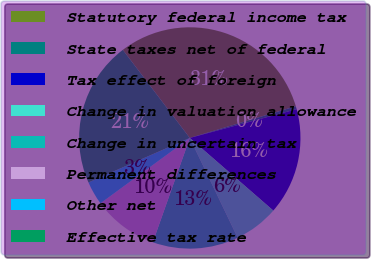Convert chart to OTSL. <chart><loc_0><loc_0><loc_500><loc_500><pie_chart><fcel>Statutory federal income tax<fcel>State taxes net of federal<fcel>Tax effect of foreign<fcel>Change in valuation allowance<fcel>Change in uncertain tax<fcel>Permanent differences<fcel>Other net<fcel>Effective tax rate<nl><fcel>30.72%<fcel>0.44%<fcel>15.58%<fcel>6.49%<fcel>12.55%<fcel>9.52%<fcel>3.47%<fcel>21.24%<nl></chart> 